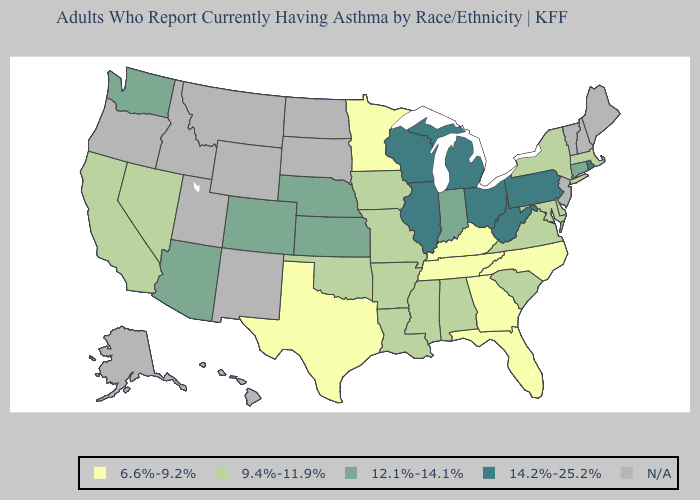Name the states that have a value in the range 12.1%-14.1%?
Answer briefly. Arizona, Colorado, Connecticut, Indiana, Kansas, Nebraska, Washington. Name the states that have a value in the range 12.1%-14.1%?
Give a very brief answer. Arizona, Colorado, Connecticut, Indiana, Kansas, Nebraska, Washington. What is the lowest value in the USA?
Write a very short answer. 6.6%-9.2%. What is the highest value in the USA?
Answer briefly. 14.2%-25.2%. Name the states that have a value in the range 12.1%-14.1%?
Give a very brief answer. Arizona, Colorado, Connecticut, Indiana, Kansas, Nebraska, Washington. Which states have the lowest value in the MidWest?
Keep it brief. Minnesota. Does the first symbol in the legend represent the smallest category?
Quick response, please. Yes. What is the value of California?
Answer briefly. 9.4%-11.9%. Name the states that have a value in the range 9.4%-11.9%?
Concise answer only. Alabama, Arkansas, California, Delaware, Iowa, Louisiana, Maryland, Massachusetts, Mississippi, Missouri, Nevada, New York, Oklahoma, South Carolina, Virginia. What is the value of New Hampshire?
Give a very brief answer. N/A. Which states have the lowest value in the South?
Short answer required. Florida, Georgia, Kentucky, North Carolina, Tennessee, Texas. Name the states that have a value in the range 6.6%-9.2%?
Keep it brief. Florida, Georgia, Kentucky, Minnesota, North Carolina, Tennessee, Texas. What is the value of Rhode Island?
Write a very short answer. 14.2%-25.2%. 